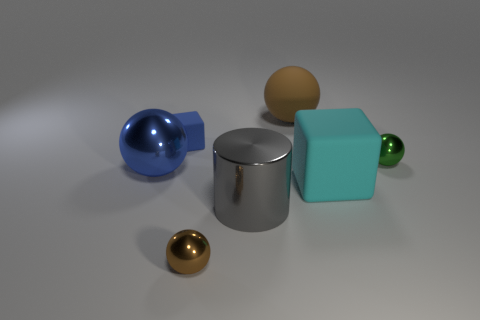Subtract all brown shiny spheres. How many spheres are left? 3 Add 1 small rubber things. How many objects exist? 8 Subtract all blue blocks. How many blocks are left? 1 Subtract all cylinders. How many objects are left? 6 Subtract 1 cylinders. How many cylinders are left? 0 Subtract all red cubes. Subtract all brown cylinders. How many cubes are left? 2 Subtract all blue cylinders. Subtract all large metal balls. How many objects are left? 6 Add 3 green metallic things. How many green metallic things are left? 4 Add 6 small blue rubber blocks. How many small blue rubber blocks exist? 7 Subtract 0 purple blocks. How many objects are left? 7 